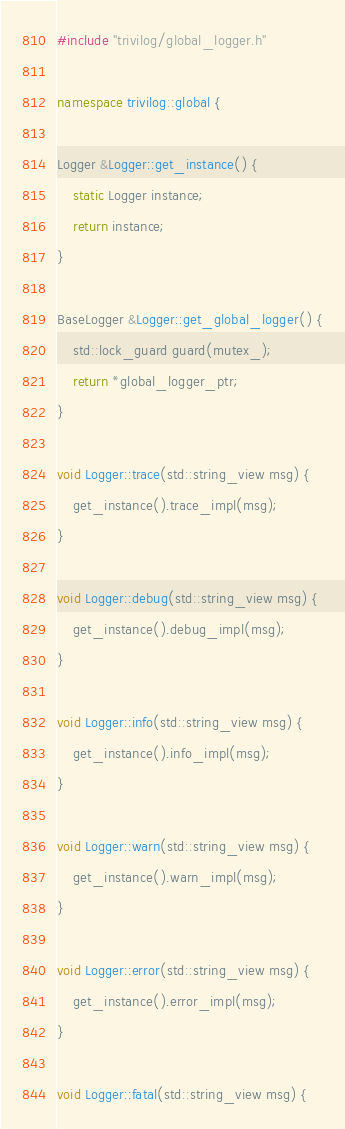<code> <loc_0><loc_0><loc_500><loc_500><_C++_>#include "trivilog/global_logger.h"

namespace trivilog::global {

Logger &Logger::get_instance() {
    static Logger instance;
    return instance;
}

BaseLogger &Logger::get_global_logger() {
    std::lock_guard guard(mutex_);
    return *global_logger_ptr;
}

void Logger::trace(std::string_view msg) {
    get_instance().trace_impl(msg);
}

void Logger::debug(std::string_view msg) {
    get_instance().debug_impl(msg);
}

void Logger::info(std::string_view msg) {
    get_instance().info_impl(msg);
}

void Logger::warn(std::string_view msg) {
    get_instance().warn_impl(msg);
}

void Logger::error(std::string_view msg) {
    get_instance().error_impl(msg);
}

void Logger::fatal(std::string_view msg) {</code> 